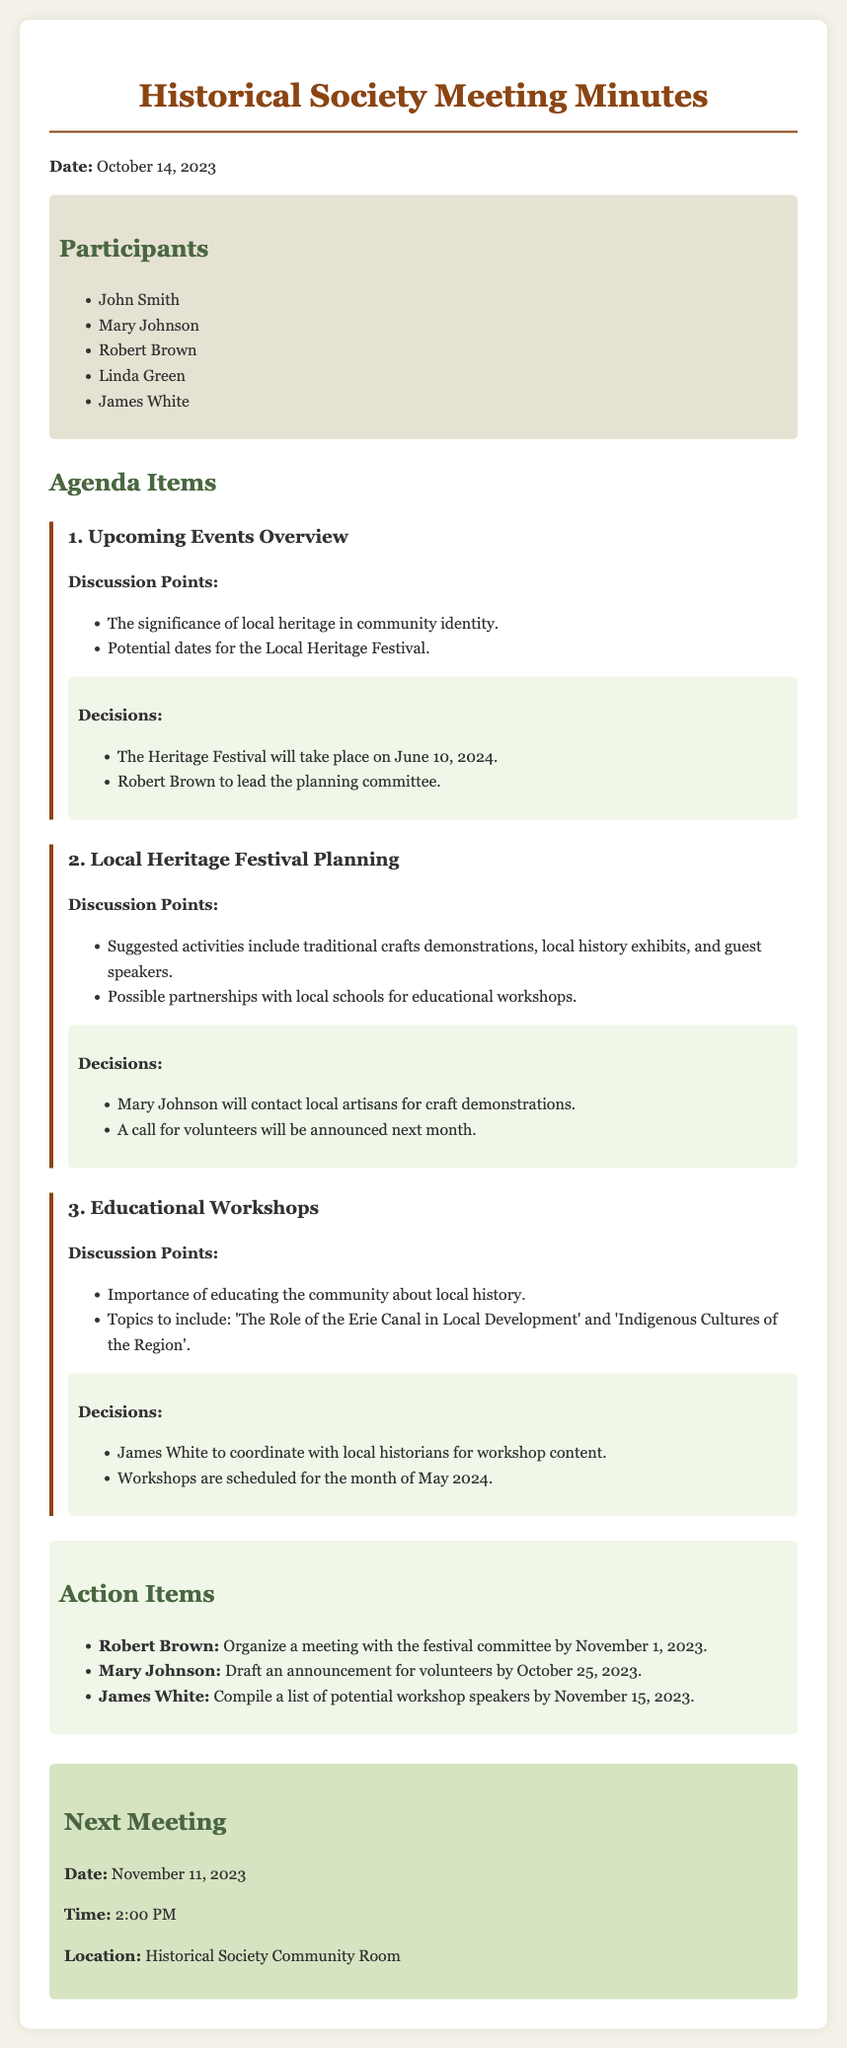What is the date of the Heritage Festival? The Heritage Festival is scheduled to take place on June 10, 2024, as mentioned in the decisions section.
Answer: June 10, 2024 Who is leading the planning committee for the Heritage Festival? Robert Brown is mentioned as the individual leading the planning committee in the document's decisions.
Answer: Robert Brown What is one of the topics for the educational workshops? The workshop topics listed include 'The Role of the Erie Canal in Local Development', which is part of the discussion points.
Answer: The Role of the Erie Canal in Local Development When is the next meeting scheduled? The next meeting date is indicated as November 11, 2023, in the next meeting section.
Answer: November 11, 2023 What action item is assigned to Mary Johnson? Mary Johnson has an action item to draft an announcement for volunteers by October 25, 2023, as stated in the action items section.
Answer: Draft an announcement for volunteers What is the suggested activity for the Heritage Festival? One suggested activity is traditional crafts demonstrations, as noted in the discussion points for local heritage festival planning.
Answer: Traditional crafts demonstrations Which participant is coordinating with local historians? James White is tasked with coordinating with local historians for workshop content according to the decisions section.
Answer: James White What is the time of the next meeting? The next meeting is scheduled for 2:00 PM, which is indicated in the next meeting section.
Answer: 2:00 PM 